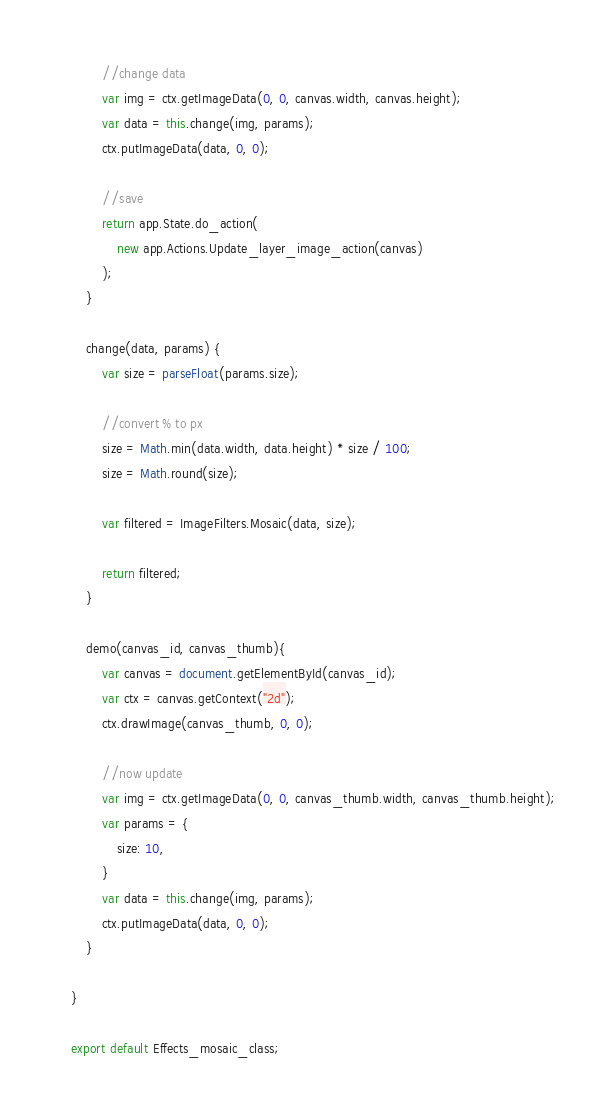<code> <loc_0><loc_0><loc_500><loc_500><_JavaScript_>		//change data
		var img = ctx.getImageData(0, 0, canvas.width, canvas.height);
		var data = this.change(img, params);
		ctx.putImageData(data, 0, 0);

		//save
		return app.State.do_action(
			new app.Actions.Update_layer_image_action(canvas)
		);
	}

	change(data, params) {
		var size = parseFloat(params.size);

		//convert % to px
		size = Math.min(data.width, data.height) * size / 100;
		size = Math.round(size);

		var filtered = ImageFilters.Mosaic(data, size);

		return filtered;
	}

	demo(canvas_id, canvas_thumb){
		var canvas = document.getElementById(canvas_id);
		var ctx = canvas.getContext("2d");
		ctx.drawImage(canvas_thumb, 0, 0);

		//now update
		var img = ctx.getImageData(0, 0, canvas_thumb.width, canvas_thumb.height);
		var params = {
			size: 10,
		}
		var data = this.change(img, params);
		ctx.putImageData(data, 0, 0);
	}

}

export default Effects_mosaic_class;</code> 